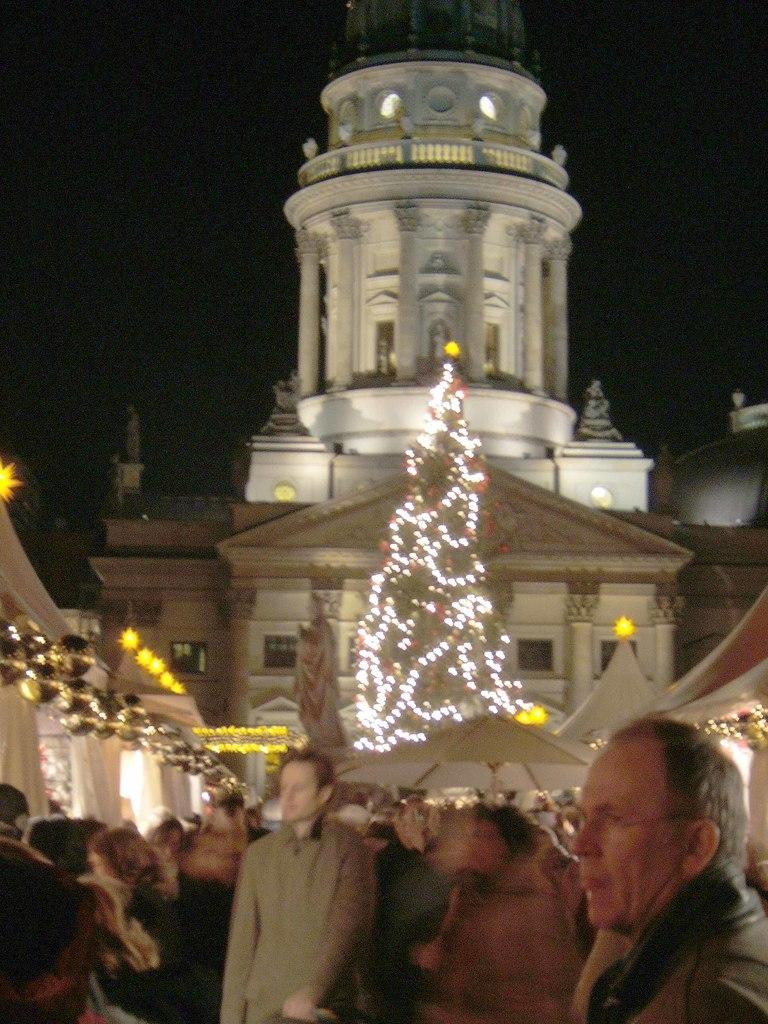What is happening on the road in the image? There is a crowd on the road in the image. What can be seen in the image besides the crowd? Lights, tents, buildings, and the sky are visible in the image. What might be the purpose of the tents in the image? The tents could be used for shelter or as a gathering place for the crowd. What is the time of day in the image? The image is likely taken during the night, as indicated by the presence of lights and the visibility of the sky in the background. What type of lace is being used to decorate the governor's speech in the image? There is no governor or speech present in the image; it features a crowd on the road, lights, tents, buildings, and the sky. 